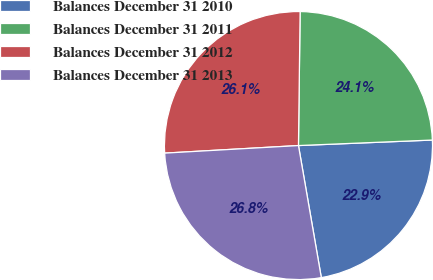Convert chart. <chart><loc_0><loc_0><loc_500><loc_500><pie_chart><fcel>Balances December 31 2010<fcel>Balances December 31 2011<fcel>Balances December 31 2012<fcel>Balances December 31 2013<nl><fcel>22.93%<fcel>24.15%<fcel>26.1%<fcel>26.83%<nl></chart> 